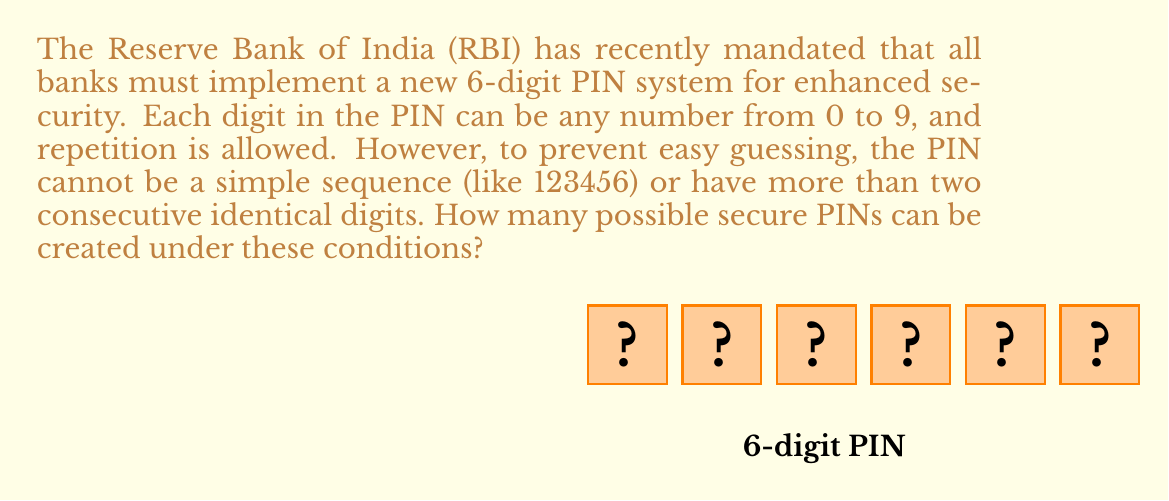Give your solution to this math problem. Let's approach this step-by-step:

1) First, let's calculate the total number of 6-digit PINs without any restrictions:
   $$10^6 = 1,000,000$$

2) Now, we need to subtract the PINs that don't meet our security criteria:

   a) Simple sequences: There are 10 possible simple sequences (012345, 123456, ..., 987654).

   b) PINs with more than two consecutive identical digits: We can calculate this as follows:
      - Choose the starting position of the three consecutive digits (4 options: 1st, 2nd, 3rd, or 4th position)
      - Choose the digit to be repeated (10 options)
      - Choose the remaining 3 digits (10 options each)
      $$4 \times 10 \times 10^3 = 40,000$$

3) However, we've double-counted some PINs that have both a simple sequence and more than two consecutive identical digits. These are:
   000000, 111111, ..., 999999 (10 in total)

4) Therefore, the total number of secure PINs is:
   $$1,000,000 - 10 - 40,000 + 10 = 959,990$$

Thus, there are 959,990 possible secure 6-digit PINs under the given conditions.
Answer: 959,990 